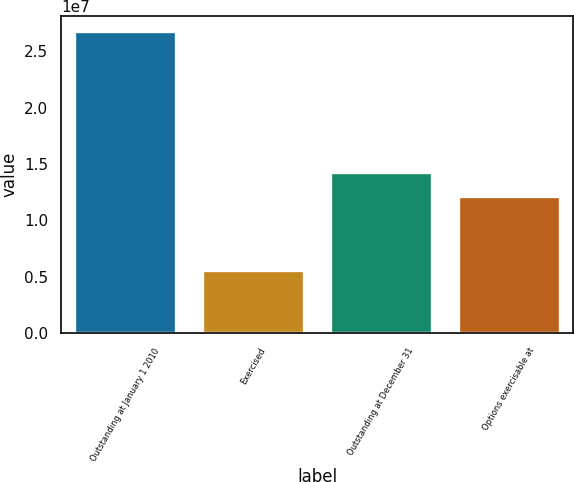Convert chart. <chart><loc_0><loc_0><loc_500><loc_500><bar_chart><fcel>Outstanding at January 1 2010<fcel>Exercised<fcel>Outstanding at December 31<fcel>Options exercisable at<nl><fcel>2.67612e+07<fcel>5.57914e+06<fcel>1.42715e+07<fcel>1.21533e+07<nl></chart> 